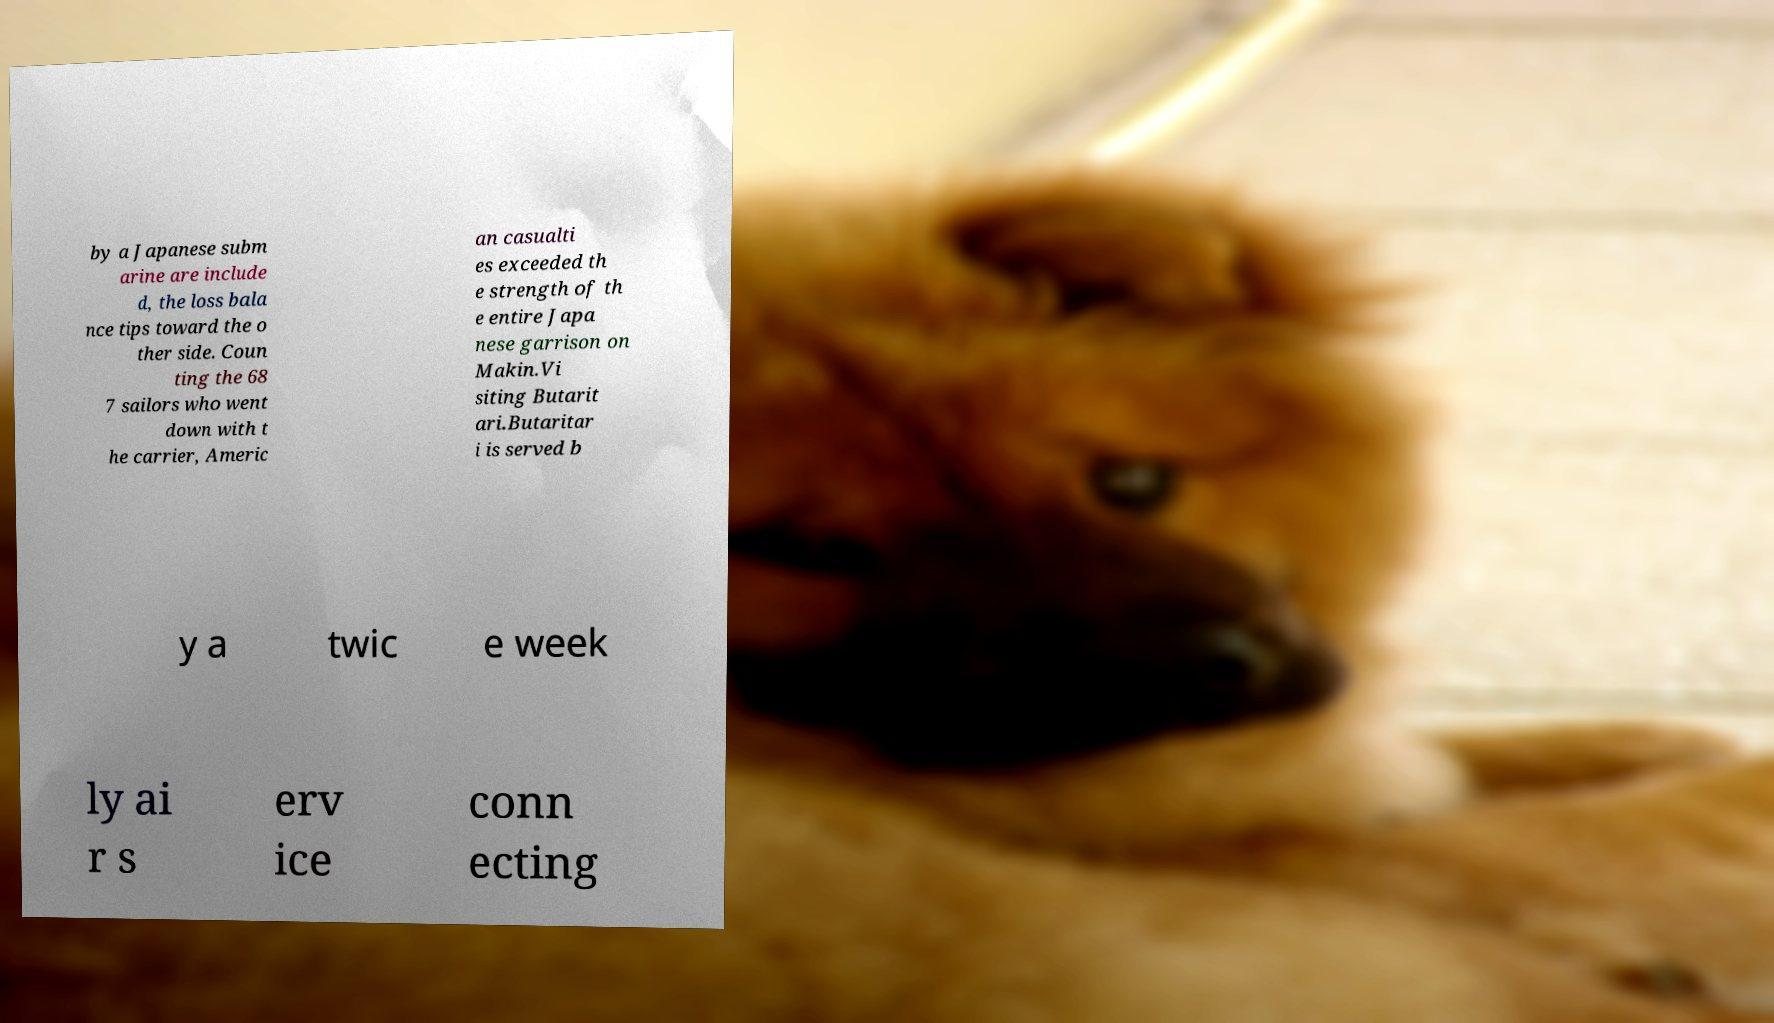Could you extract and type out the text from this image? by a Japanese subm arine are include d, the loss bala nce tips toward the o ther side. Coun ting the 68 7 sailors who went down with t he carrier, Americ an casualti es exceeded th e strength of th e entire Japa nese garrison on Makin.Vi siting Butarit ari.Butaritar i is served b y a twic e week ly ai r s erv ice conn ecting 